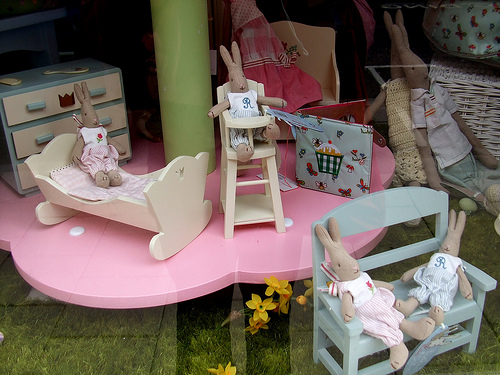<image>
Is the chair on the table? Yes. Looking at the image, I can see the chair is positioned on top of the table, with the table providing support. Is the bench on the table? No. The bench is not positioned on the table. They may be near each other, but the bench is not supported by or resting on top of the table. 